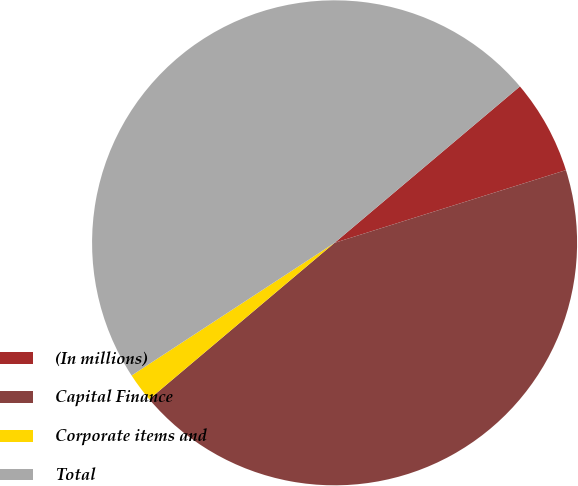<chart> <loc_0><loc_0><loc_500><loc_500><pie_chart><fcel>(In millions)<fcel>Capital Finance<fcel>Corporate items and<fcel>Total<nl><fcel>6.31%<fcel>43.69%<fcel>1.94%<fcel>48.06%<nl></chart> 